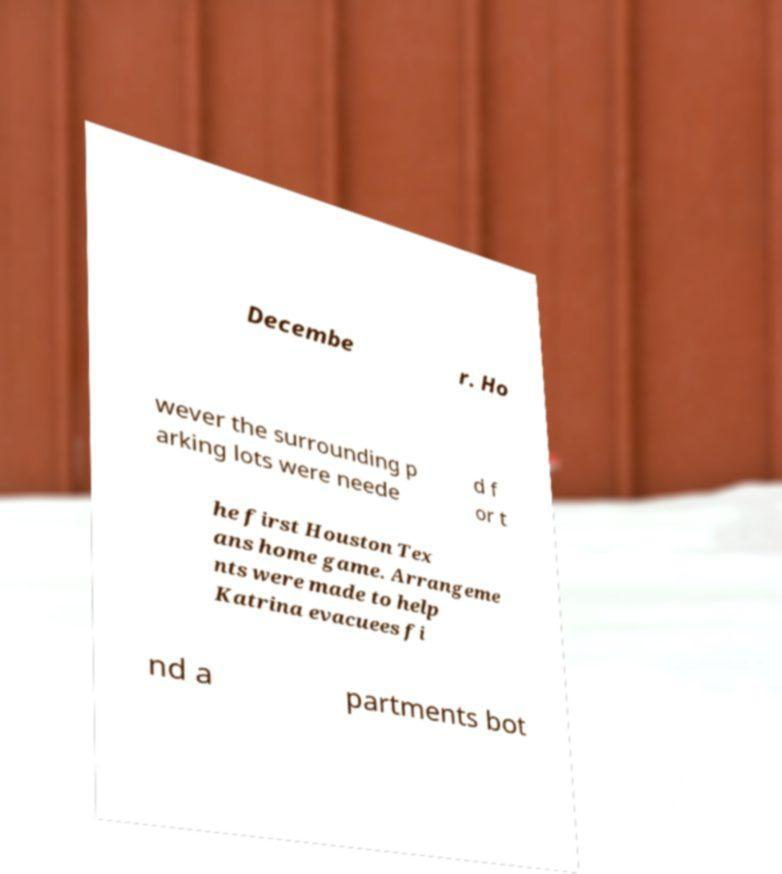There's text embedded in this image that I need extracted. Can you transcribe it verbatim? Decembe r. Ho wever the surrounding p arking lots were neede d f or t he first Houston Tex ans home game. Arrangeme nts were made to help Katrina evacuees fi nd a partments bot 